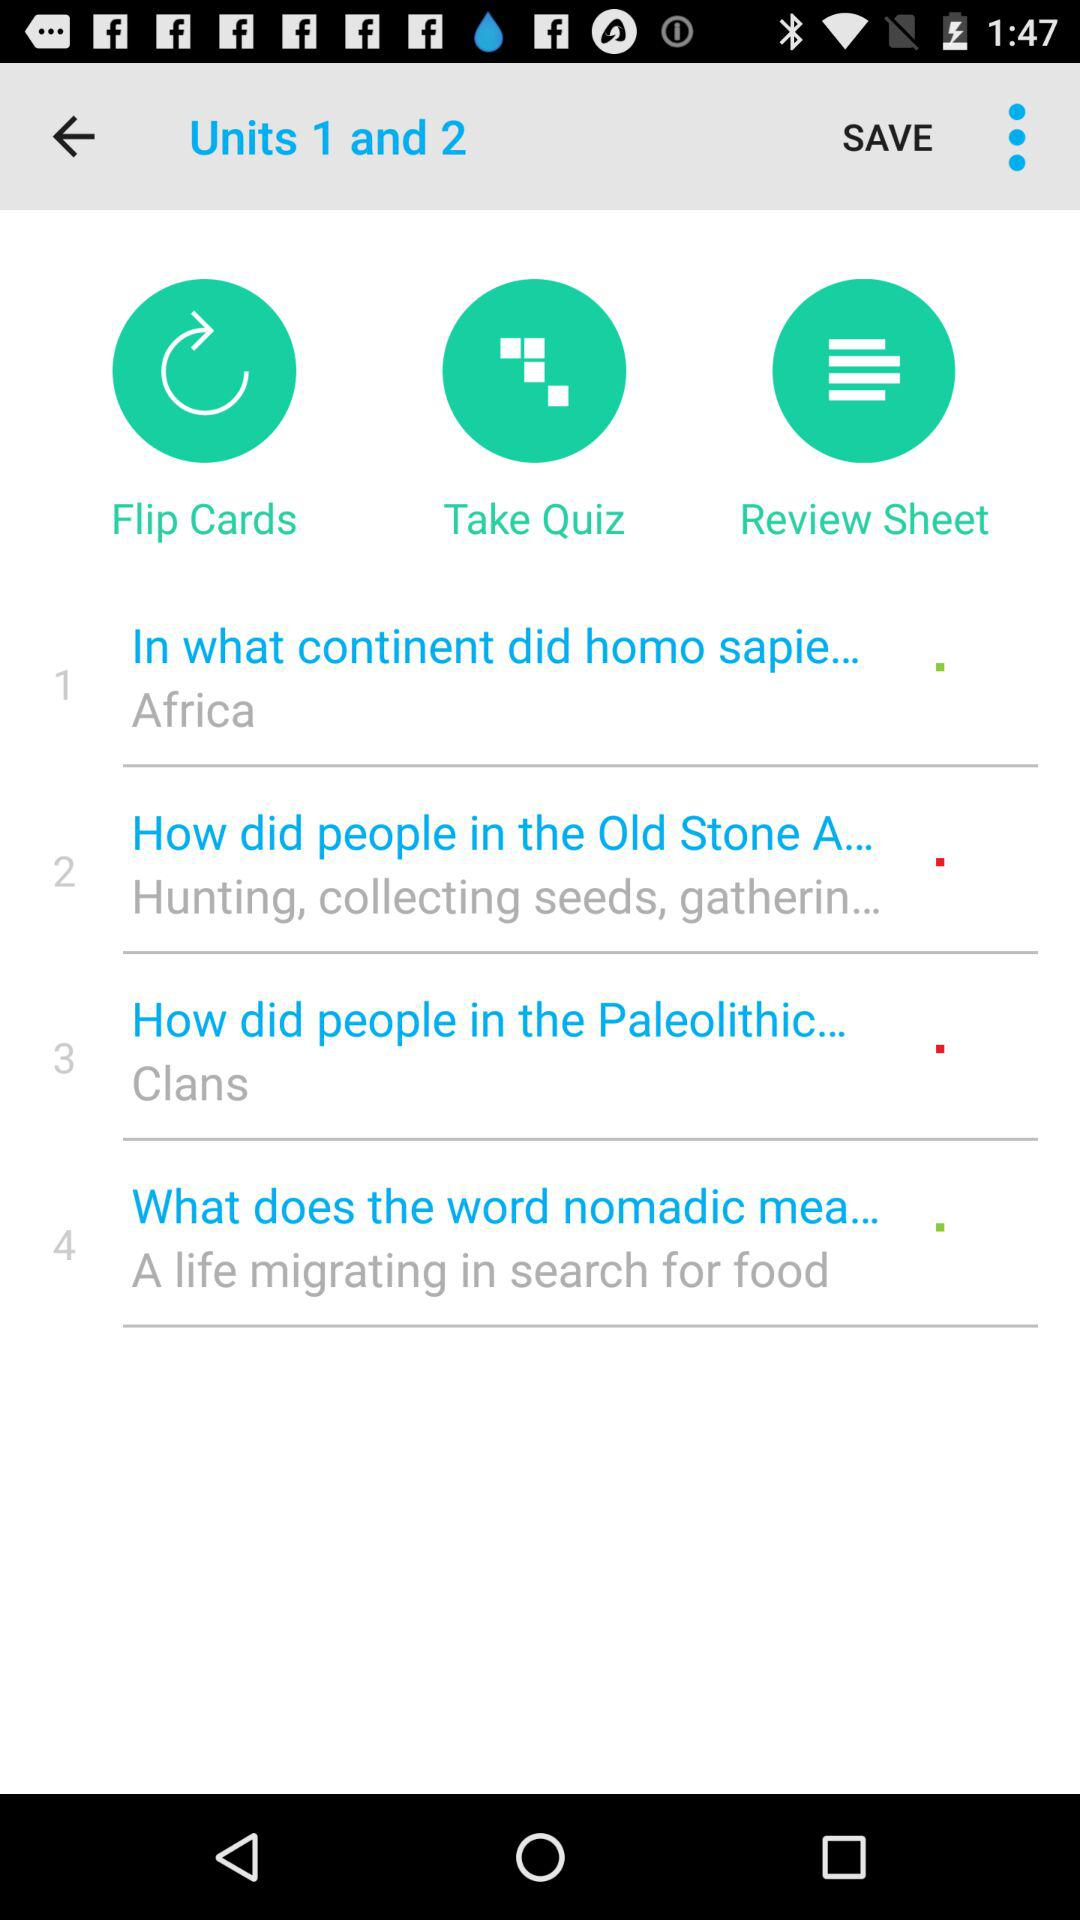How many text inputs are present on the screen?
Answer the question using a single word or phrase. 4 